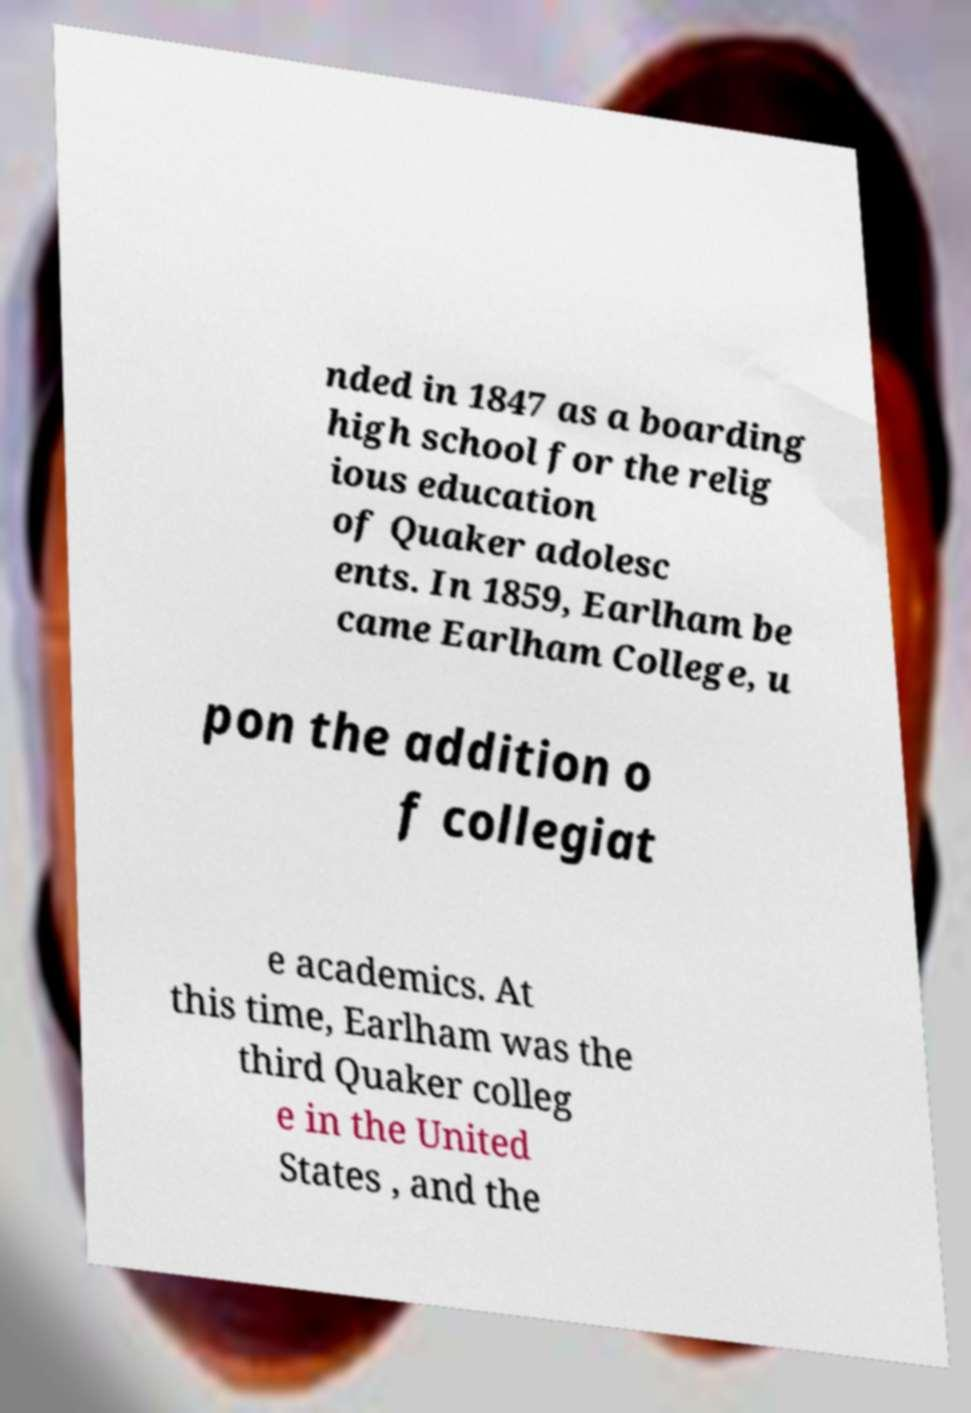I need the written content from this picture converted into text. Can you do that? nded in 1847 as a boarding high school for the relig ious education of Quaker adolesc ents. In 1859, Earlham be came Earlham College, u pon the addition o f collegiat e academics. At this time, Earlham was the third Quaker colleg e in the United States , and the 